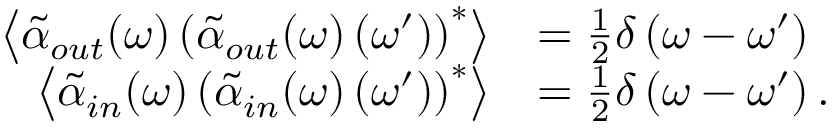Convert formula to latex. <formula><loc_0><loc_0><loc_500><loc_500>\begin{array} { r l } { \left \langle \tilde { \alpha } _ { o u t } ( \omega ) \left ( \tilde { \alpha } _ { o u t } ( \omega ) \left ( \omega ^ { \prime } \right ) \right ) ^ { * } \right \rangle } & { = \frac { 1 } { 2 } \delta \left ( \omega - \omega ^ { \prime } \right ) } \\ { \left \langle \tilde { \alpha } _ { i n } ( \omega ) \left ( \tilde { \alpha } _ { i n } ( \omega ) \left ( \omega ^ { \prime } \right ) \right ) ^ { * } \right \rangle } & { = \frac { 1 } { 2 } \delta \left ( \omega - \omega ^ { \prime } \right ) . } \end{array}</formula> 